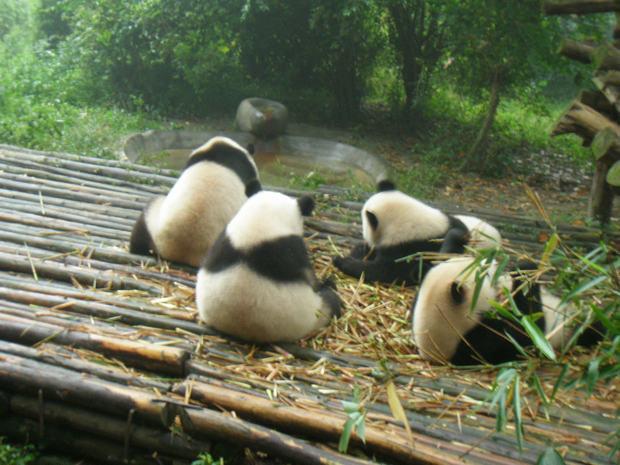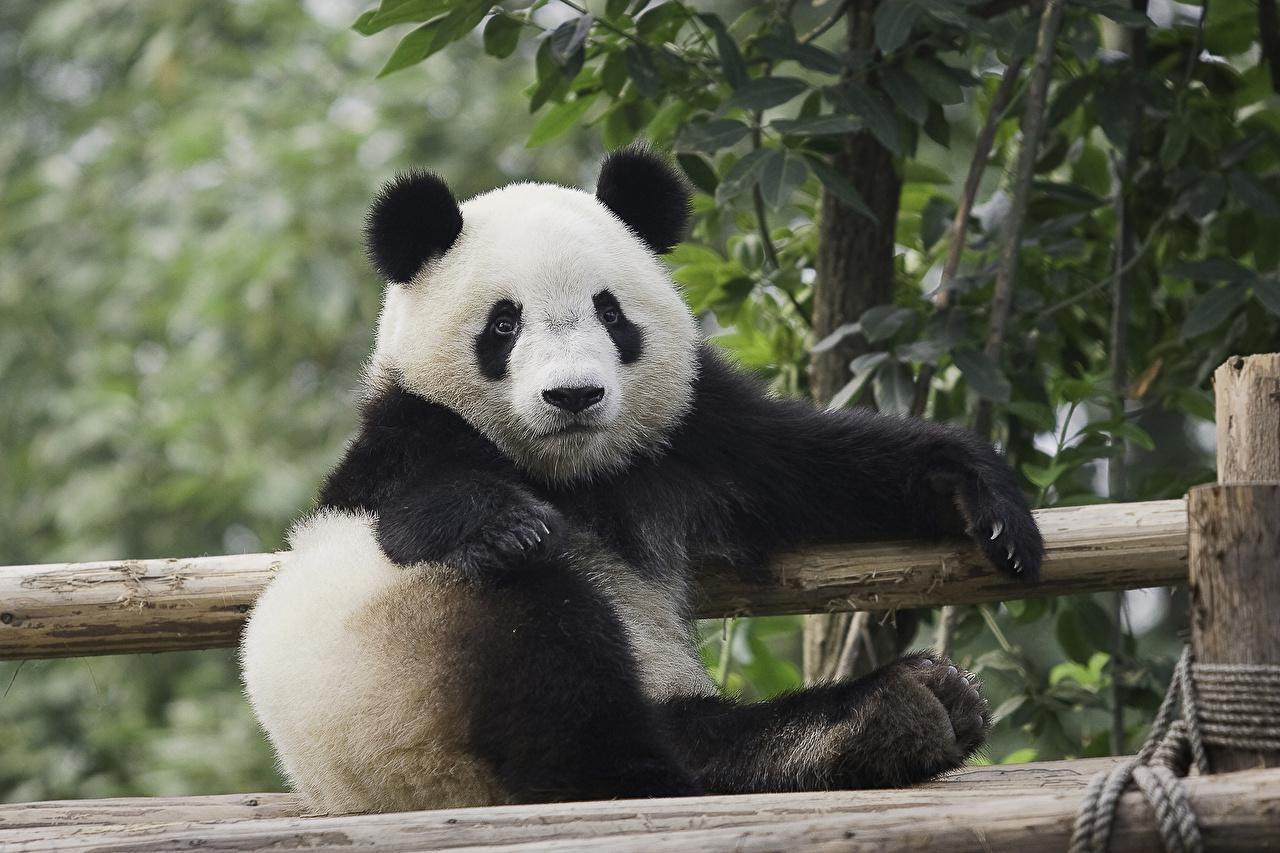The first image is the image on the left, the second image is the image on the right. Given the left and right images, does the statement "Two pandas are laying forward." hold true? Answer yes or no. No. 